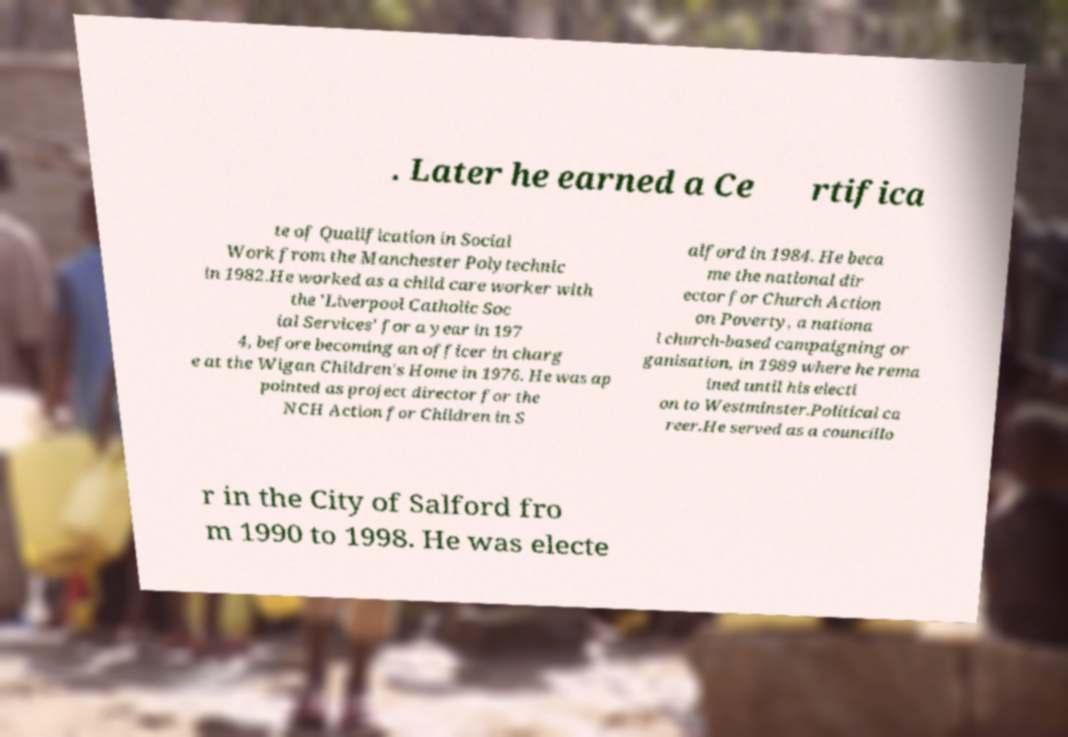Please read and relay the text visible in this image. What does it say? . Later he earned a Ce rtifica te of Qualification in Social Work from the Manchester Polytechnic in 1982.He worked as a child care worker with the 'Liverpool Catholic Soc ial Services' for a year in 197 4, before becoming an officer in charg e at the Wigan Children's Home in 1976. He was ap pointed as project director for the NCH Action for Children in S alford in 1984. He beca me the national dir ector for Church Action on Poverty, a nationa l church-based campaigning or ganisation, in 1989 where he rema ined until his electi on to Westminster.Political ca reer.He served as a councillo r in the City of Salford fro m 1990 to 1998. He was electe 